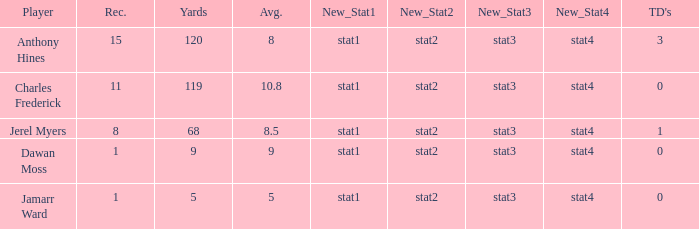What is the highest number of TDs when the Avg is larger than 8.5 and the Rec is less than 1? None. 